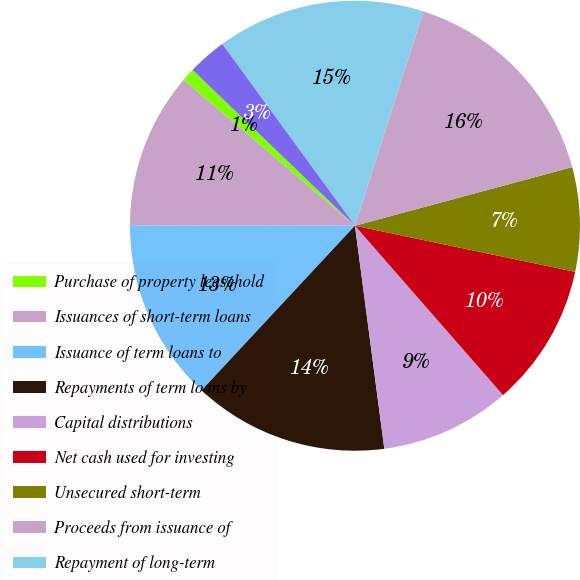<chart> <loc_0><loc_0><loc_500><loc_500><pie_chart><fcel>Purchase of property leasehold<fcel>Issuances of short-term loans<fcel>Issuance of term loans to<fcel>Repayments of term loans by<fcel>Capital distributions<fcel>Net cash used for investing<fcel>Unsecured short-term<fcel>Proceeds from issuance of<fcel>Repayment of long-term<fcel>Purchase of APEX trust<nl><fcel>0.94%<fcel>11.21%<fcel>13.08%<fcel>14.02%<fcel>9.35%<fcel>10.28%<fcel>7.48%<fcel>15.89%<fcel>14.95%<fcel>2.8%<nl></chart> 